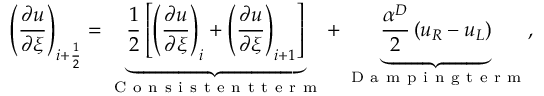<formula> <loc_0><loc_0><loc_500><loc_500>\left ( \frac { \partial u } { \partial \xi } \right ) _ { i + \frac { 1 } { 2 } } = \underbrace { \frac { 1 } { 2 } \left [ \left ( \frac { \partial u } { \partial \xi } \right ) _ { i } + \left ( \frac { \partial u } { \partial \xi } \right ) _ { i + 1 } \right ] } _ { C o n s i s t e n t t e r m } + \underbrace { \frac { \alpha ^ { D } } { 2 } \left ( u _ { R } - u _ { L } \right ) } _ { D a m p i n g t e r m } ,</formula> 